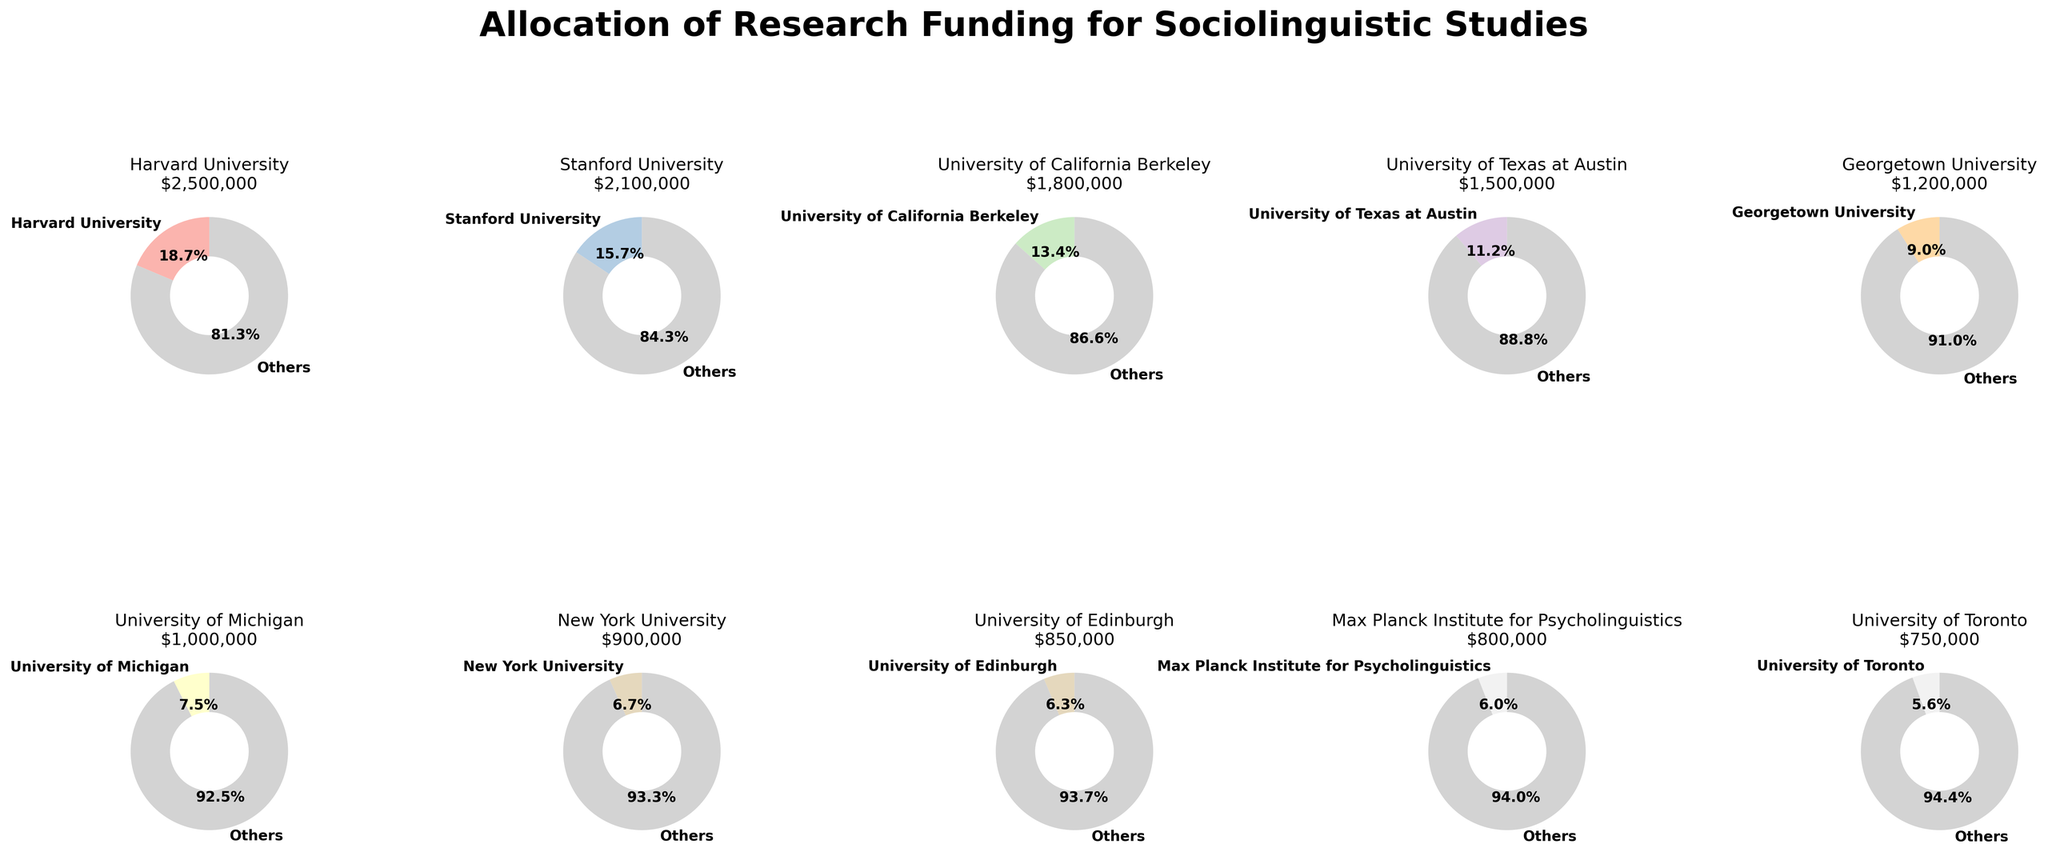Which institution received the highest funding? The pie chart slices indicate the amount of funding each institution received, labeled with the institution's name and the funding amount. By comparing the values, the institution with the highest funding is Harvard University with $2,500,000.
Answer: Harvard University Which institution received the least funding? Similar to identifying the highest funding, comparing the values on the chart reveals that the University of Toronto received the lowest funding at $750,000.
Answer: University of Toronto How much more funding did Harvard University receive compared to Stanford University? Harvard University received $2,500,000, and Stanford University received $2,100,000. Subtracting these amounts, $2,500,000 - $2,100,000 = $400,000.
Answer: $400,000 What percentage of the total funding did Georgetown University receive? Georgetown University's pie chart slice shows its funding amount of $1,200,000. To find the percentage, divide $1,200,000 by the total funding and multiply by 100. The total funding is $13,800,000. So, ($1,200,000 / $13,800,000) * 100 ≈ 8.7%.
Answer: 8.7% Which institutions received more funding than the University of Michigan? The pie chart for the University of Michigan shows $1,000,000. Harvard University, Stanford University, University of California Berkeley, University of Texas at Austin, and Georgetown University all received more funding than the University of Michigan.
Answer: Harvard University, Stanford University, University of California Berkeley, University of Texas at Austin, Georgetown University What is the combined funding of Max Planck Institute for Psycholinguistics and University of Toronto? The Max Planck Institute for Psycholinguistics received $800,000, and the University of Toronto received $750,000. Adding these together results in $800,000 + $750,000 = $1,550,000.
Answer: $1,550,000 How does the funding received by New York University compare to that received by University of Edinburgh? New York University received $900,000, and University of Edinburgh received $850,000. Therefore, New York University received $50,000 more.
Answer: $50,000 more What is the percentage difference in funding between University of California Berkeley and University of Texas at Austin? University of California Berkeley received $1,800,000, and University of Texas at Austin received $1,500,000. The difference is $300,000. The percentage difference is calculated as ($300,000 / $1,800,000) * 100 ≈ 16.7%.
Answer: 16.7% What is the average funding amount across all institutions? Summing all the funding amounts yields $13,800,000. There are 10 institutions. The average is calculated as $13,800,000 / 10 = $1,380,000.
Answer: $1,380,000 What fraction of the total funding is received by the University of Texas at Austin? The University of Texas at Austin received $1,500,000. To find the fraction of the total funding, divide that by the total funding: $1,500,000 / $13,800,000 = 15/138 or approximately 1/9.
Answer: 1/9 